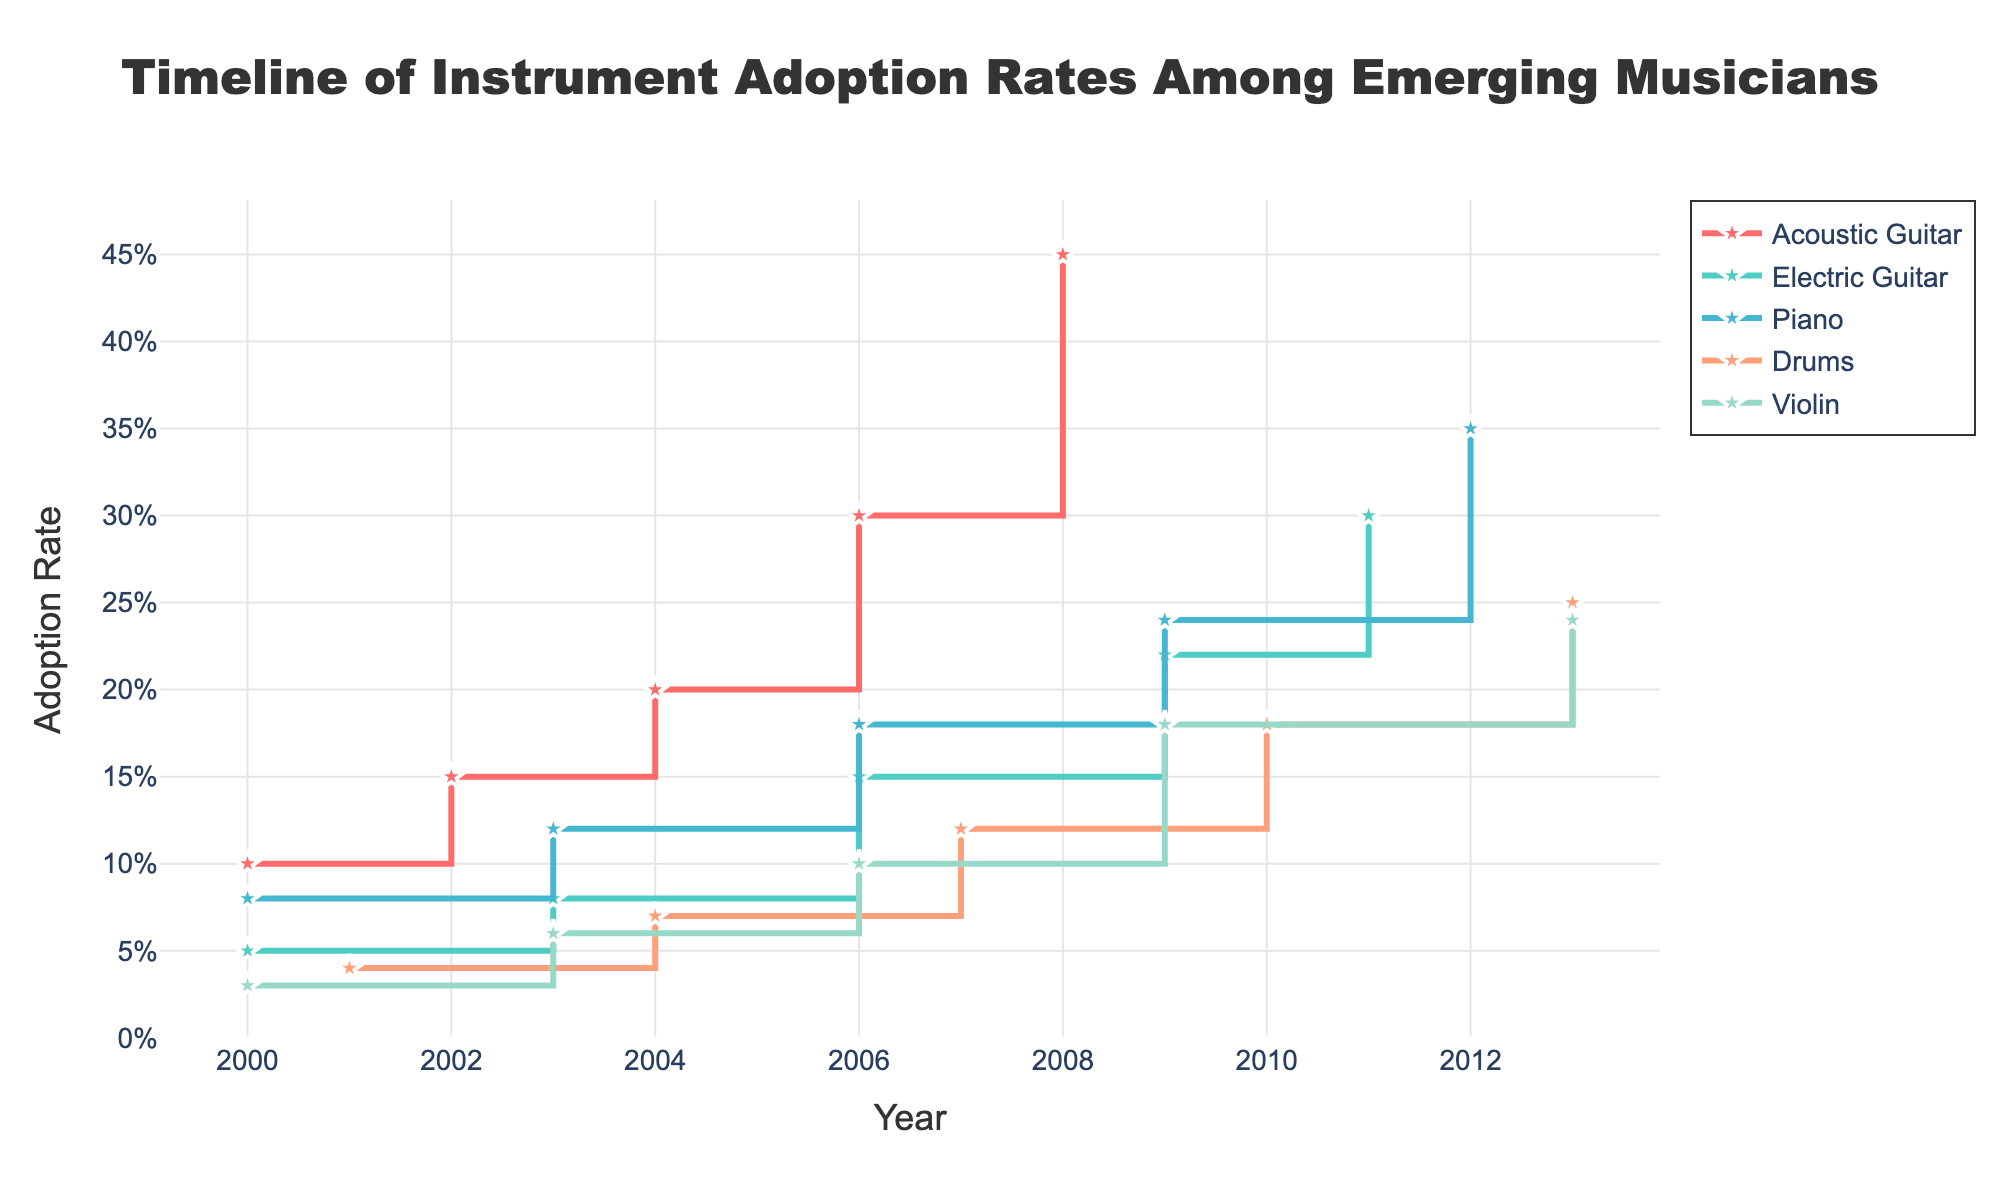what is plotted on the y-axis? The y-axis shows the adoption rate of each instrument, represented as a percentage of musicians who have adopted the instrument over time.
Answer: Adoption rate Which instrument had the highest adoption rate in 2000? From the plot, the acoustic guitar had the highest adoption rate in 2000, with a rate of 10%.
Answer: Acoustic guitar What year did the electric guitar’s adoption rate reach 15%? According to the plot, the electric guitar's adoption rate reached 15% in 2006.
Answer: 2006 How does the adoption rate of the piano in 2009 compare to that of the electric guitar in the same year? From the plot, the piano had an adoption rate of 24% in 2009, while the electric guitar had an adoption rate of 22%. Therefore, the piano had a higher adoption rate in 2009.
Answer: Piano had a higher adoption rate What is the average adoption rate of the drums from 2001 to 2013? The adoption rates of the drums in the years mentioned are 4%, 7%, 12%, 18%, and 25%. The average adoption rate is calculated by summing these rates and dividing by the number of years: (4 + 7 + 12 + 18 + 25)/5 = 66/5 = 13.2%.
Answer: 13.2% In which year did the violin reach an adoption rate of 18%? According to the plot, the violin reached an adoption rate of 18% in 2009.
Answer: 2009 Which instrument shows the most rapid increase in adoption rate between consecutive years? By observing the plot, the acoustic guitar shows a significant increase between 2004 and 2006, from 20% to 30%, indicating a rapid increase of 10% over two years.
Answer: Acoustic guitar What is the difference in the adoption rate of the acoustic guitar and the piano in 2006? In 2006, the adoption rate for the acoustic guitar was 30%, and for the piano, it was 18%. The difference is 30% - 18% = 12%.
Answer: 12% Which instrument maintained a consistent increase in adoption rate without any drop or plateau? The drum shows a consistent increase in adoption rate over the years without any drop or plateau, as observed from the plot.
Answer: Drums By how much did the adoption rate of the violin increase from 2000 to 2013? The violin's adoption rate increased from 3% in 2000 to 24% in 2013. The increase is calculated as 24% - 3% = 21%.
Answer: 21% 